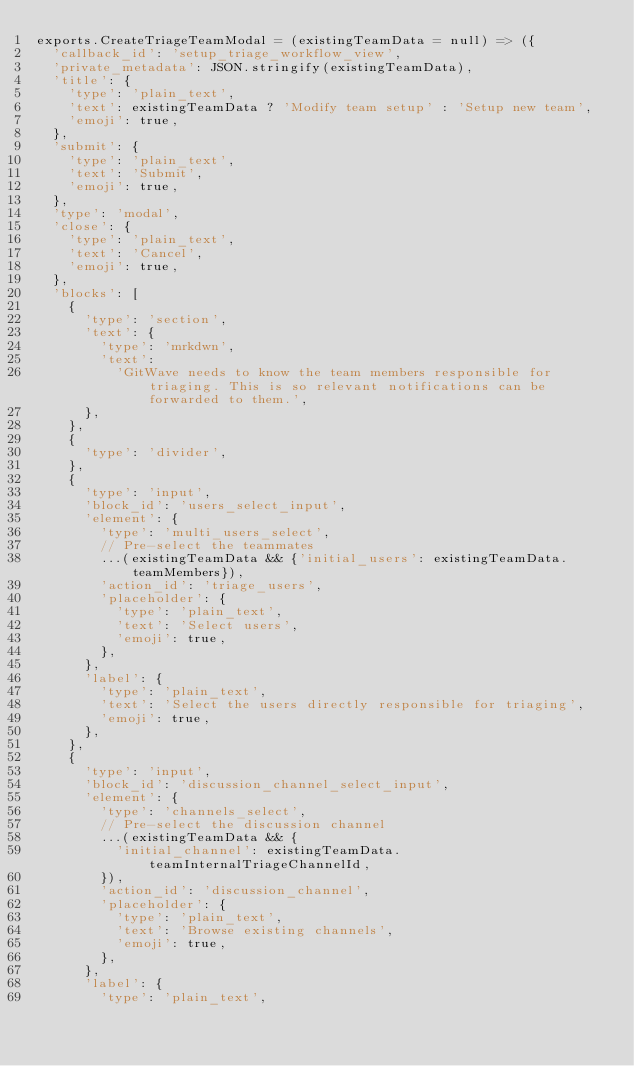<code> <loc_0><loc_0><loc_500><loc_500><_JavaScript_>exports.CreateTriageTeamModal = (existingTeamData = null) => ({
  'callback_id': 'setup_triage_workflow_view',
  'private_metadata': JSON.stringify(existingTeamData),
  'title': {
    'type': 'plain_text',
    'text': existingTeamData ? 'Modify team setup' : 'Setup new team',
    'emoji': true,
  },
  'submit': {
    'type': 'plain_text',
    'text': 'Submit',
    'emoji': true,
  },
  'type': 'modal',
  'close': {
    'type': 'plain_text',
    'text': 'Cancel',
    'emoji': true,
  },
  'blocks': [
    {
      'type': 'section',
      'text': {
        'type': 'mrkdwn',
        'text':
          'GitWave needs to know the team members responsible for triaging. This is so relevant notifications can be forwarded to them.',
      },
    },
    {
      'type': 'divider',
    },
    {
      'type': 'input',
      'block_id': 'users_select_input',
      'element': {
        'type': 'multi_users_select',
        // Pre-select the teammates
        ...(existingTeamData && {'initial_users': existingTeamData.teamMembers}),
        'action_id': 'triage_users',
        'placeholder': {
          'type': 'plain_text',
          'text': 'Select users',
          'emoji': true,
        },
      },
      'label': {
        'type': 'plain_text',
        'text': 'Select the users directly responsible for triaging',
        'emoji': true,
      },
    },
    {
      'type': 'input',
      'block_id': 'discussion_channel_select_input',
      'element': {
        'type': 'channels_select',
        // Pre-select the discussion channel
        ...(existingTeamData && {
          'initial_channel': existingTeamData.teamInternalTriageChannelId,
        }),
        'action_id': 'discussion_channel',
        'placeholder': {
          'type': 'plain_text',
          'text': 'Browse existing channels',
          'emoji': true,
        },
      },
      'label': {
        'type': 'plain_text',</code> 